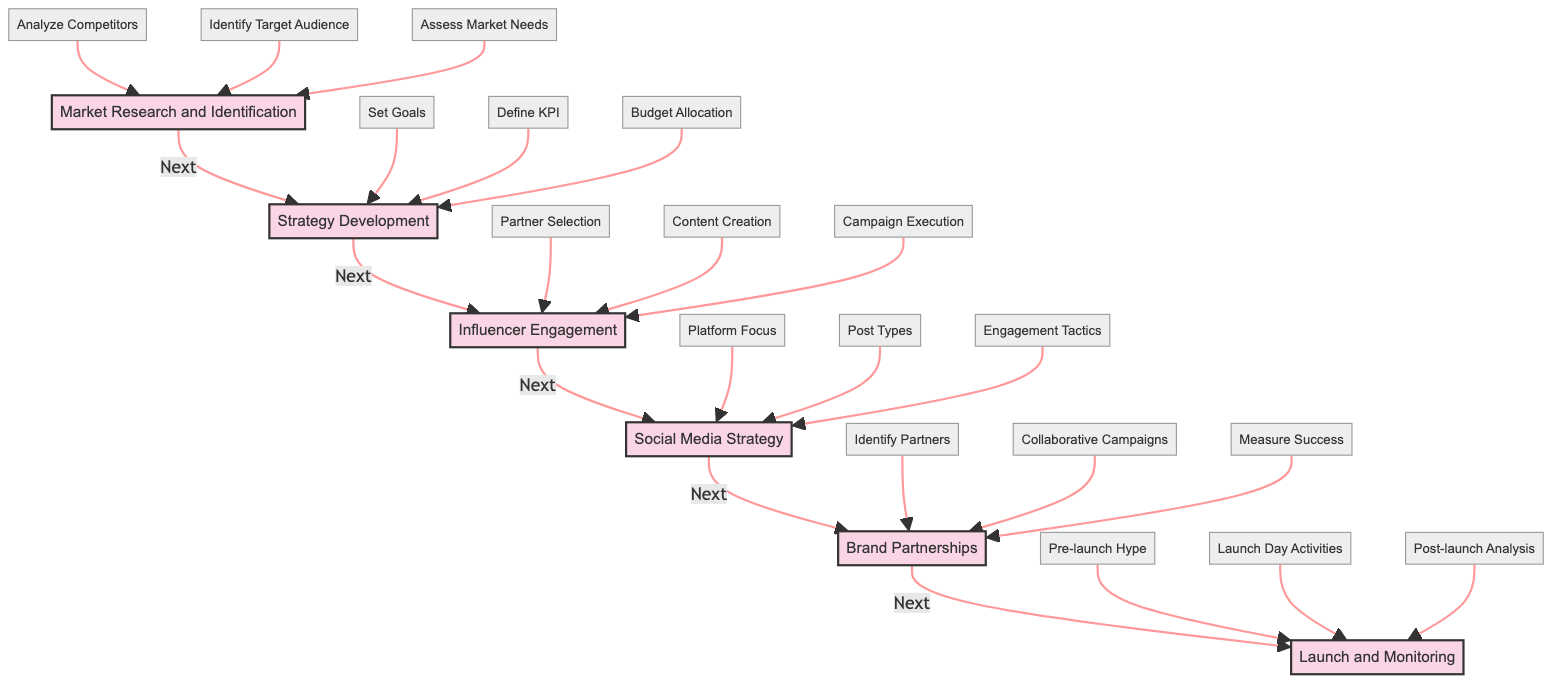What's the first stage in the pathway? The diagram indicates that "Market Research and Identification" is the first stage, as it is the starting point and has no incoming edges.
Answer: Market Research and Identification How many stages are there in total? By counting the stages listed in the diagram, there are six distinct stages from Market Research and Identification to Launch and Monitoring.
Answer: Six What is the last component of the "Launch and Monitoring" stage? The last component listed for the "Launch and Monitoring" stage is "Post-launch Analysis," as it appears last in the components list for that stage.
Answer: Post-launch Analysis Which stage comes after "Influencer Engagement"? Following the flow of the diagram, the stage that comes directly after "Influencer Engagement" is "Social Media Strategy."
Answer: Social Media Strategy What are the types of platforms focused on in the "Social Media Strategy" stage? The diagram shows that the platforms focused on are Instagram, TikTok, and Facebook as specified in the "Platform Focus" component within that stage.
Answer: Instagram, TikTok, Facebook How many components are in the "Brand Partnerships" stage? The "Brand Partnerships" stage contains three components: "Identify Partners," "Collaborative Campaigns," and "Measure Success." Counting these gives a total of three components.
Answer: Three What is the first action described under the "Strategy Development" stage? In the "Strategy Development" stage, the first action listed is "Set Goals," which indicates the initial focus of this stage.
Answer: Set Goals What type of content is planned during "Influencer Engagement"? "Content Creation," which includes product demos and user testimonials, is the type of content planned during the "Influencer Engagement" stage according to the components defined.
Answer: Product Demos, User Testimonials Which stage involves measuring success through sales data? The "Brand Partnerships" stage involves measuring success using sales data as one of its components.
Answer: Brand Partnerships 